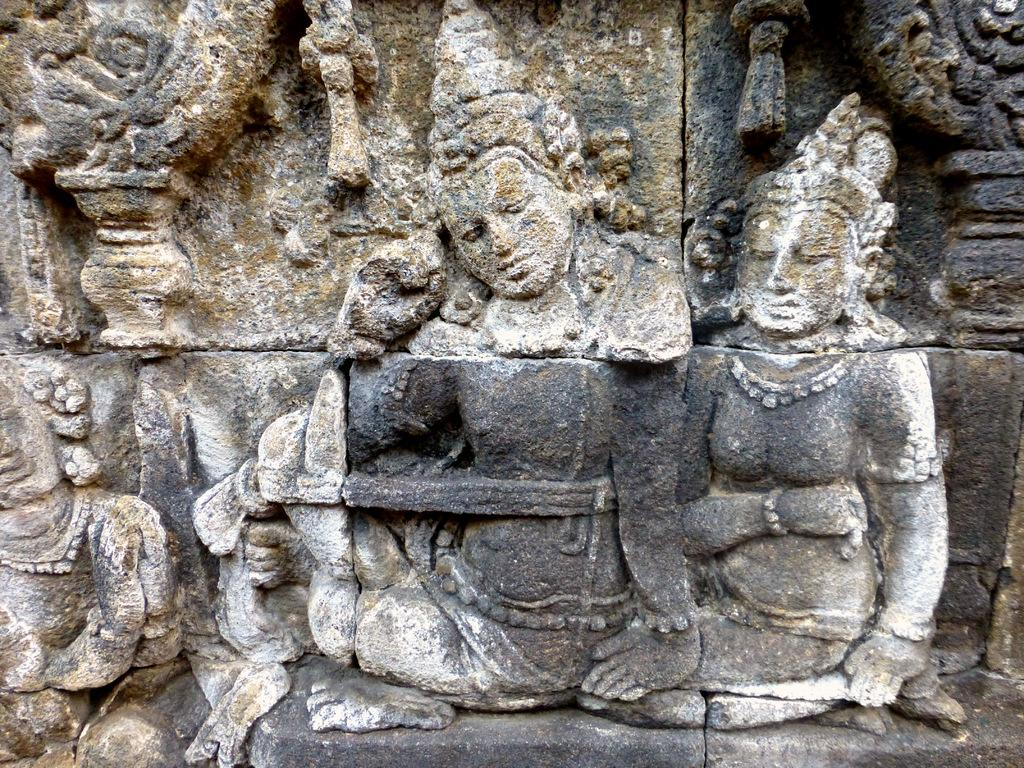What is present on the wall in the image? There are sculptures on the wall in the image. How many boats are visible in the image? There are no boats present in the image; it features sculptures on the wall. What type of feather can be seen interacting with the sculptures in the image? There is no feather present in the image; it only features sculptures on the wall. 